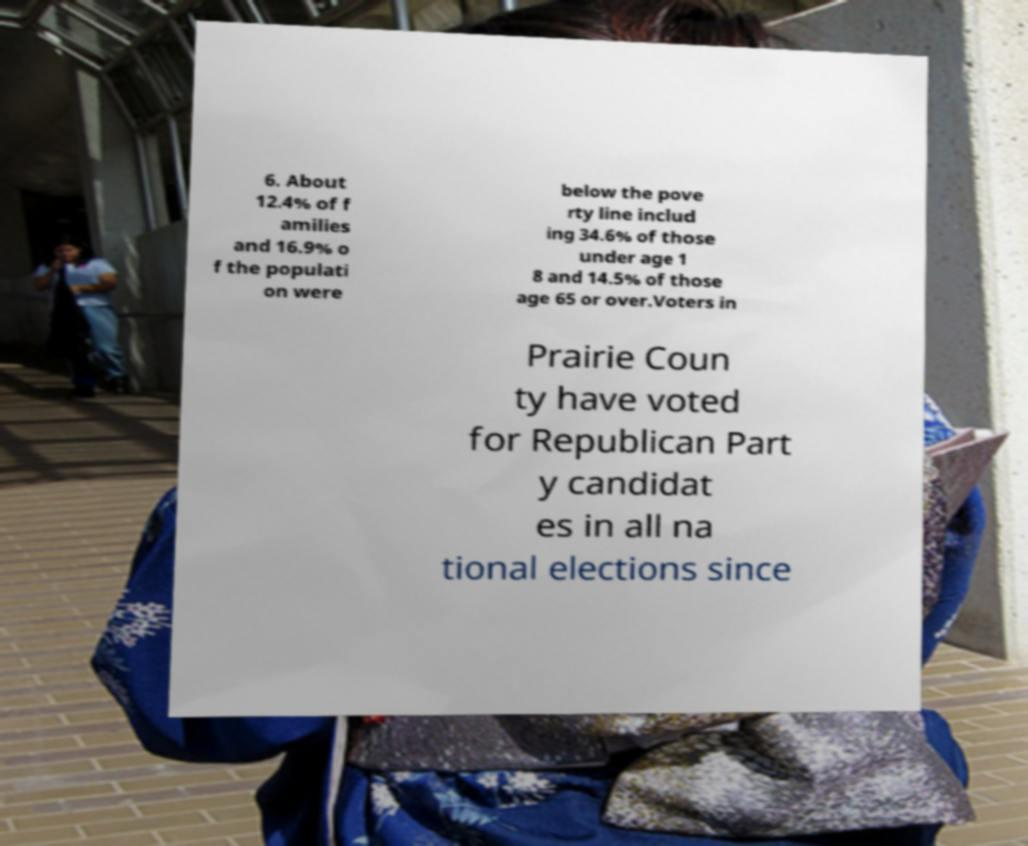What messages or text are displayed in this image? I need them in a readable, typed format. 6. About 12.4% of f amilies and 16.9% o f the populati on were below the pove rty line includ ing 34.6% of those under age 1 8 and 14.5% of those age 65 or over.Voters in Prairie Coun ty have voted for Republican Part y candidat es in all na tional elections since 